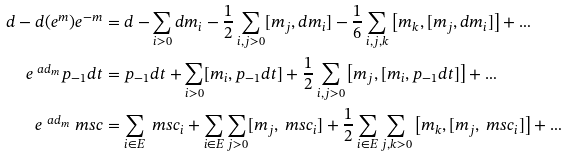Convert formula to latex. <formula><loc_0><loc_0><loc_500><loc_500>d - d ( e ^ { m } ) e ^ { - m } & = d - \sum _ { i > 0 } d m _ { i } - \frac { 1 } { 2 } \sum _ { i , j > 0 } [ m _ { j } , d m _ { i } ] - \frac { 1 } { 6 } \sum _ { i , j , k } \left [ m _ { k } , [ m _ { j } , d m _ { i } ] \right ] + \dots \\ e ^ { \ a d _ { m } } p _ { - 1 } d t & = p _ { - 1 } d t + \sum _ { i > 0 } [ m _ { i } , p _ { - 1 } d t ] + \frac { 1 } { 2 } \sum _ { i , j > 0 } \left [ m _ { j } , [ m _ { i } , p _ { - 1 } d t ] \right ] + \dots \\ e ^ { \ a d _ { m } } \ m s c & = \sum _ { i \in E } \ m s c _ { i } + \sum _ { i \in E } \sum _ { j > 0 } [ m _ { j } , \ m s c _ { i } ] + \frac { 1 } { 2 } \sum _ { i \in E } \sum _ { j , k > 0 } \left [ m _ { k } , [ m _ { j } , \ m s c _ { i } ] \right ] + \dots</formula> 